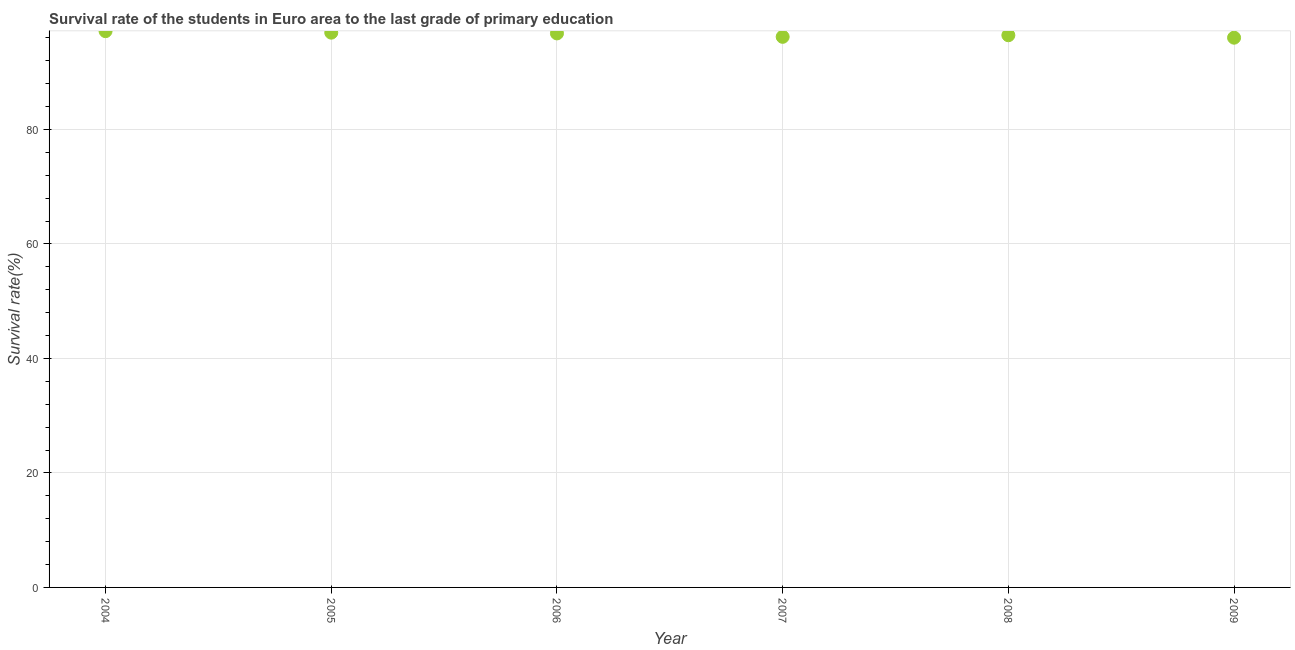What is the survival rate in primary education in 2007?
Provide a short and direct response. 96.19. Across all years, what is the maximum survival rate in primary education?
Give a very brief answer. 97.18. Across all years, what is the minimum survival rate in primary education?
Provide a succinct answer. 96.04. What is the sum of the survival rate in primary education?
Offer a terse response. 579.57. What is the difference between the survival rate in primary education in 2005 and 2006?
Your answer should be compact. 0.13. What is the average survival rate in primary education per year?
Ensure brevity in your answer.  96.59. What is the median survival rate in primary education?
Your answer should be very brief. 96.63. In how many years, is the survival rate in primary education greater than 16 %?
Your answer should be very brief. 6. What is the ratio of the survival rate in primary education in 2006 to that in 2009?
Give a very brief answer. 1.01. Is the survival rate in primary education in 2004 less than that in 2007?
Provide a succinct answer. No. What is the difference between the highest and the second highest survival rate in primary education?
Give a very brief answer. 0.26. Is the sum of the survival rate in primary education in 2005 and 2006 greater than the maximum survival rate in primary education across all years?
Offer a terse response. Yes. What is the difference between the highest and the lowest survival rate in primary education?
Make the answer very short. 1.14. In how many years, is the survival rate in primary education greater than the average survival rate in primary education taken over all years?
Provide a succinct answer. 3. How many years are there in the graph?
Your answer should be very brief. 6. Does the graph contain any zero values?
Offer a terse response. No. What is the title of the graph?
Offer a very short reply. Survival rate of the students in Euro area to the last grade of primary education. What is the label or title of the Y-axis?
Provide a short and direct response. Survival rate(%). What is the Survival rate(%) in 2004?
Offer a very short reply. 97.18. What is the Survival rate(%) in 2005?
Provide a short and direct response. 96.92. What is the Survival rate(%) in 2006?
Ensure brevity in your answer.  96.78. What is the Survival rate(%) in 2007?
Your answer should be compact. 96.19. What is the Survival rate(%) in 2008?
Your response must be concise. 96.47. What is the Survival rate(%) in 2009?
Keep it short and to the point. 96.04. What is the difference between the Survival rate(%) in 2004 and 2005?
Offer a terse response. 0.26. What is the difference between the Survival rate(%) in 2004 and 2006?
Your answer should be compact. 0.4. What is the difference between the Survival rate(%) in 2004 and 2007?
Keep it short and to the point. 0.99. What is the difference between the Survival rate(%) in 2004 and 2008?
Keep it short and to the point. 0.71. What is the difference between the Survival rate(%) in 2004 and 2009?
Your answer should be compact. 1.14. What is the difference between the Survival rate(%) in 2005 and 2006?
Ensure brevity in your answer.  0.13. What is the difference between the Survival rate(%) in 2005 and 2007?
Offer a very short reply. 0.73. What is the difference between the Survival rate(%) in 2005 and 2008?
Your response must be concise. 0.45. What is the difference between the Survival rate(%) in 2005 and 2009?
Offer a terse response. 0.88. What is the difference between the Survival rate(%) in 2006 and 2007?
Offer a terse response. 0.6. What is the difference between the Survival rate(%) in 2006 and 2008?
Provide a succinct answer. 0.32. What is the difference between the Survival rate(%) in 2006 and 2009?
Provide a succinct answer. 0.75. What is the difference between the Survival rate(%) in 2007 and 2008?
Make the answer very short. -0.28. What is the difference between the Survival rate(%) in 2007 and 2009?
Your answer should be very brief. 0.15. What is the difference between the Survival rate(%) in 2008 and 2009?
Your answer should be very brief. 0.43. What is the ratio of the Survival rate(%) in 2004 to that in 2006?
Ensure brevity in your answer.  1. What is the ratio of the Survival rate(%) in 2004 to that in 2007?
Provide a short and direct response. 1.01. What is the ratio of the Survival rate(%) in 2004 to that in 2009?
Keep it short and to the point. 1.01. What is the ratio of the Survival rate(%) in 2005 to that in 2006?
Make the answer very short. 1. What is the ratio of the Survival rate(%) in 2005 to that in 2007?
Give a very brief answer. 1.01. What is the ratio of the Survival rate(%) in 2006 to that in 2007?
Your response must be concise. 1.01. What is the ratio of the Survival rate(%) in 2006 to that in 2009?
Your answer should be very brief. 1.01. What is the ratio of the Survival rate(%) in 2007 to that in 2008?
Provide a short and direct response. 1. What is the ratio of the Survival rate(%) in 2007 to that in 2009?
Make the answer very short. 1. 